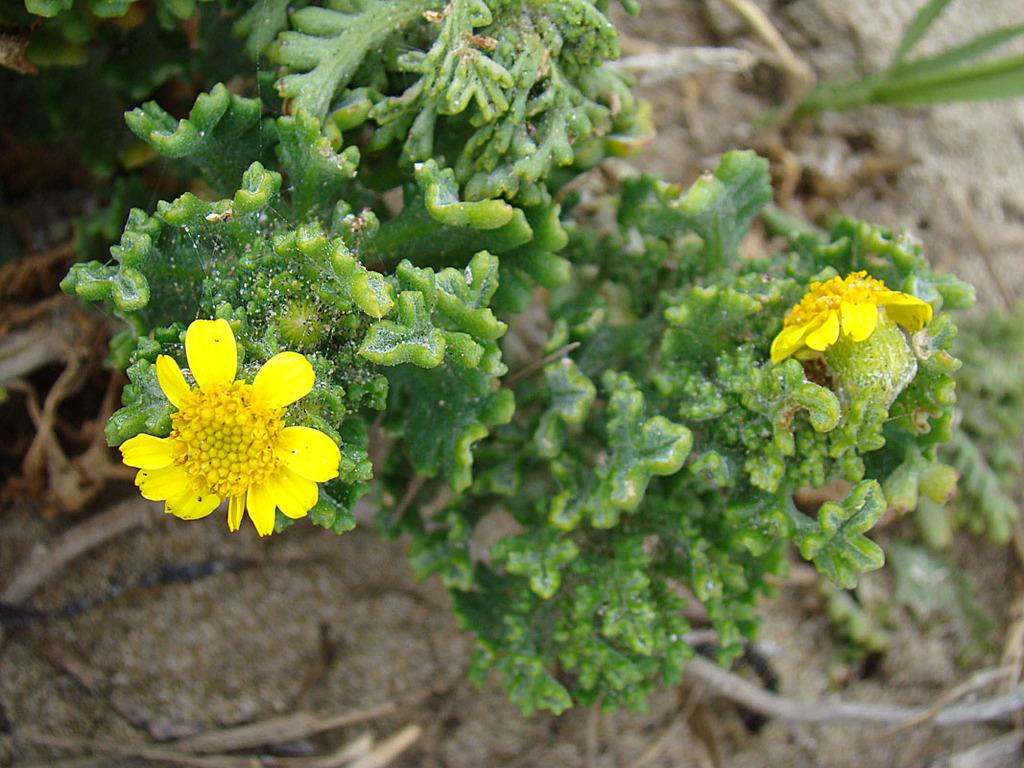What is located in the foreground of the image? There is a plant in the foreground of the image. What color are the flowers on the plant? The plant has two yellow flowers. What can be seen in the background of the image? There are sticks and sand visible in the background of the image. Where is the calculator placed in the image? There is no calculator present in the image. What type of throne can be seen in the background of the image? There is no throne present in the image. 